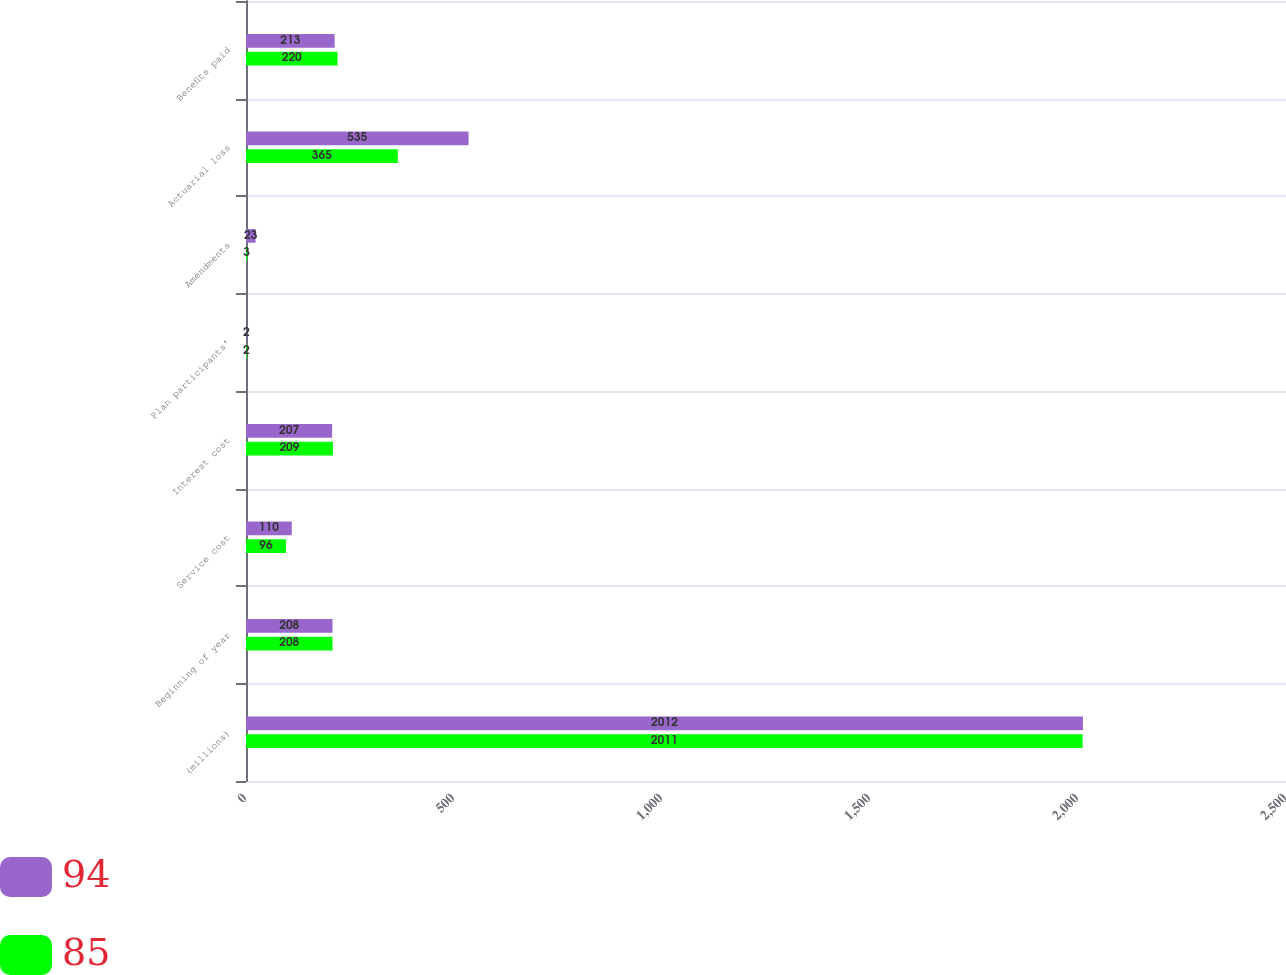Convert chart to OTSL. <chart><loc_0><loc_0><loc_500><loc_500><stacked_bar_chart><ecel><fcel>(millions)<fcel>Beginning of year<fcel>Service cost<fcel>Interest cost<fcel>Plan participants'<fcel>Amendments<fcel>Actuarial loss<fcel>Benefits paid<nl><fcel>94<fcel>2012<fcel>208<fcel>110<fcel>207<fcel>2<fcel>23<fcel>535<fcel>213<nl><fcel>85<fcel>2011<fcel>208<fcel>96<fcel>209<fcel>2<fcel>3<fcel>365<fcel>220<nl></chart> 